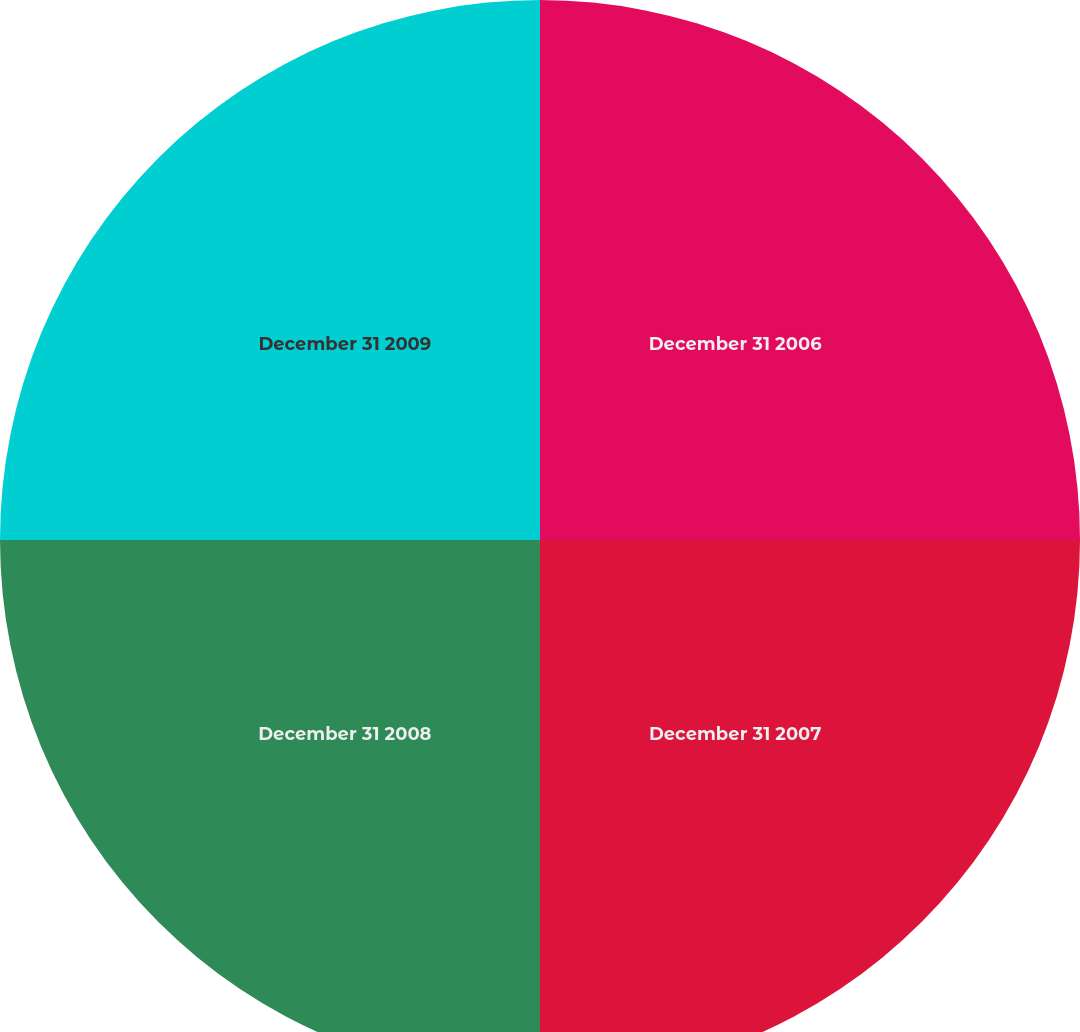Convert chart to OTSL. <chart><loc_0><loc_0><loc_500><loc_500><pie_chart><fcel>December 31 2006<fcel>December 31 2007<fcel>December 31 2008<fcel>December 31 2009<nl><fcel>25.0%<fcel>25.0%<fcel>25.0%<fcel>25.0%<nl></chart> 